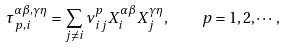Convert formula to latex. <formula><loc_0><loc_0><loc_500><loc_500>\tau ^ { \alpha \beta , \gamma \eta } _ { p , i } = \sum _ { j \neq i } \nu _ { i j } ^ { p } X _ { i } ^ { \alpha \beta } X _ { j } ^ { \gamma \eta } , \quad p = 1 , 2 , \cdots ,</formula> 